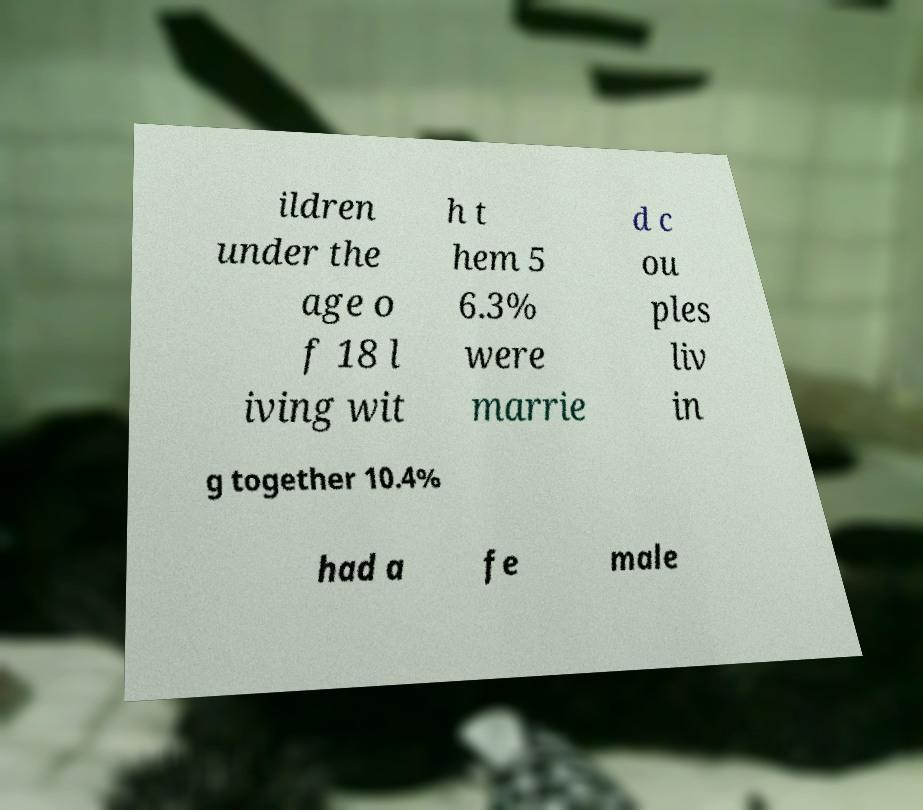Could you assist in decoding the text presented in this image and type it out clearly? ildren under the age o f 18 l iving wit h t hem 5 6.3% were marrie d c ou ples liv in g together 10.4% had a fe male 